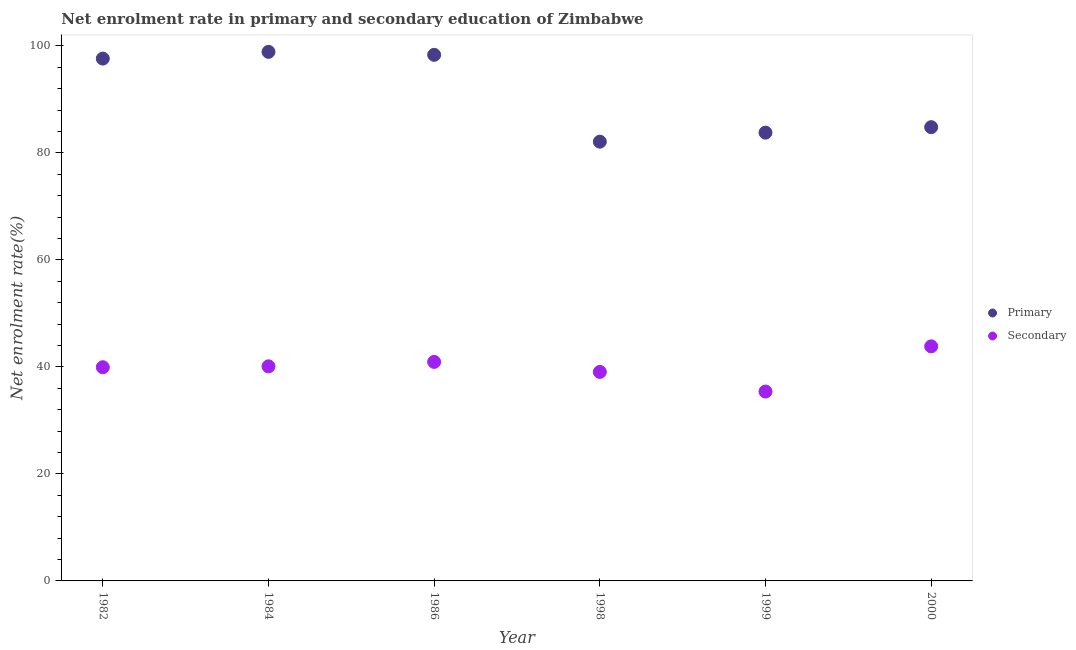How many different coloured dotlines are there?
Your response must be concise. 2. Is the number of dotlines equal to the number of legend labels?
Your answer should be very brief. Yes. What is the enrollment rate in secondary education in 2000?
Your answer should be very brief. 43.84. Across all years, what is the maximum enrollment rate in primary education?
Give a very brief answer. 98.88. Across all years, what is the minimum enrollment rate in primary education?
Ensure brevity in your answer.  82.1. In which year was the enrollment rate in secondary education maximum?
Provide a succinct answer. 2000. In which year was the enrollment rate in primary education minimum?
Your answer should be very brief. 1998. What is the total enrollment rate in secondary education in the graph?
Make the answer very short. 239.28. What is the difference between the enrollment rate in primary education in 1984 and that in 1998?
Ensure brevity in your answer.  16.79. What is the difference between the enrollment rate in secondary education in 1986 and the enrollment rate in primary education in 1984?
Keep it short and to the point. -57.95. What is the average enrollment rate in primary education per year?
Make the answer very short. 90.92. In the year 1999, what is the difference between the enrollment rate in primary education and enrollment rate in secondary education?
Make the answer very short. 48.39. What is the ratio of the enrollment rate in secondary education in 1986 to that in 1998?
Offer a terse response. 1.05. Is the difference between the enrollment rate in primary education in 1982 and 1999 greater than the difference between the enrollment rate in secondary education in 1982 and 1999?
Provide a succinct answer. Yes. What is the difference between the highest and the second highest enrollment rate in secondary education?
Offer a terse response. 2.9. What is the difference between the highest and the lowest enrollment rate in secondary education?
Make the answer very short. 8.44. In how many years, is the enrollment rate in primary education greater than the average enrollment rate in primary education taken over all years?
Provide a short and direct response. 3. Is the enrollment rate in secondary education strictly greater than the enrollment rate in primary education over the years?
Keep it short and to the point. No. Does the graph contain any zero values?
Your response must be concise. No. How many legend labels are there?
Keep it short and to the point. 2. How are the legend labels stacked?
Offer a very short reply. Vertical. What is the title of the graph?
Keep it short and to the point. Net enrolment rate in primary and secondary education of Zimbabwe. Does "Excluding technical cooperation" appear as one of the legend labels in the graph?
Your answer should be compact. No. What is the label or title of the X-axis?
Make the answer very short. Year. What is the label or title of the Y-axis?
Your response must be concise. Net enrolment rate(%). What is the Net enrolment rate(%) in Primary in 1982?
Keep it short and to the point. 97.63. What is the Net enrolment rate(%) in Secondary in 1982?
Your answer should be very brief. 39.94. What is the Net enrolment rate(%) in Primary in 1984?
Make the answer very short. 98.88. What is the Net enrolment rate(%) in Secondary in 1984?
Your answer should be compact. 40.11. What is the Net enrolment rate(%) in Primary in 1986?
Ensure brevity in your answer.  98.33. What is the Net enrolment rate(%) in Secondary in 1986?
Your answer should be compact. 40.93. What is the Net enrolment rate(%) of Primary in 1998?
Your answer should be compact. 82.1. What is the Net enrolment rate(%) of Secondary in 1998?
Your response must be concise. 39.07. What is the Net enrolment rate(%) in Primary in 1999?
Your answer should be very brief. 83.78. What is the Net enrolment rate(%) of Secondary in 1999?
Keep it short and to the point. 35.4. What is the Net enrolment rate(%) of Primary in 2000?
Make the answer very short. 84.81. What is the Net enrolment rate(%) in Secondary in 2000?
Provide a short and direct response. 43.84. Across all years, what is the maximum Net enrolment rate(%) of Primary?
Your answer should be compact. 98.88. Across all years, what is the maximum Net enrolment rate(%) of Secondary?
Provide a succinct answer. 43.84. Across all years, what is the minimum Net enrolment rate(%) in Primary?
Keep it short and to the point. 82.1. Across all years, what is the minimum Net enrolment rate(%) of Secondary?
Your answer should be compact. 35.4. What is the total Net enrolment rate(%) in Primary in the graph?
Keep it short and to the point. 545.52. What is the total Net enrolment rate(%) in Secondary in the graph?
Make the answer very short. 239.28. What is the difference between the Net enrolment rate(%) in Primary in 1982 and that in 1984?
Offer a terse response. -1.26. What is the difference between the Net enrolment rate(%) in Secondary in 1982 and that in 1984?
Offer a terse response. -0.17. What is the difference between the Net enrolment rate(%) of Primary in 1982 and that in 1986?
Your response must be concise. -0.7. What is the difference between the Net enrolment rate(%) in Secondary in 1982 and that in 1986?
Ensure brevity in your answer.  -0.99. What is the difference between the Net enrolment rate(%) of Primary in 1982 and that in 1998?
Provide a short and direct response. 15.53. What is the difference between the Net enrolment rate(%) of Secondary in 1982 and that in 1998?
Give a very brief answer. 0.87. What is the difference between the Net enrolment rate(%) in Primary in 1982 and that in 1999?
Keep it short and to the point. 13.84. What is the difference between the Net enrolment rate(%) of Secondary in 1982 and that in 1999?
Provide a succinct answer. 4.54. What is the difference between the Net enrolment rate(%) in Primary in 1982 and that in 2000?
Keep it short and to the point. 12.82. What is the difference between the Net enrolment rate(%) of Secondary in 1982 and that in 2000?
Give a very brief answer. -3.9. What is the difference between the Net enrolment rate(%) of Primary in 1984 and that in 1986?
Your response must be concise. 0.56. What is the difference between the Net enrolment rate(%) of Secondary in 1984 and that in 1986?
Provide a short and direct response. -0.83. What is the difference between the Net enrolment rate(%) of Primary in 1984 and that in 1998?
Your answer should be compact. 16.79. What is the difference between the Net enrolment rate(%) of Secondary in 1984 and that in 1998?
Provide a succinct answer. 1.04. What is the difference between the Net enrolment rate(%) of Primary in 1984 and that in 1999?
Provide a short and direct response. 15.1. What is the difference between the Net enrolment rate(%) of Secondary in 1984 and that in 1999?
Ensure brevity in your answer.  4.71. What is the difference between the Net enrolment rate(%) in Primary in 1984 and that in 2000?
Your answer should be very brief. 14.07. What is the difference between the Net enrolment rate(%) of Secondary in 1984 and that in 2000?
Ensure brevity in your answer.  -3.73. What is the difference between the Net enrolment rate(%) of Primary in 1986 and that in 1998?
Your response must be concise. 16.23. What is the difference between the Net enrolment rate(%) of Secondary in 1986 and that in 1998?
Give a very brief answer. 1.87. What is the difference between the Net enrolment rate(%) of Primary in 1986 and that in 1999?
Keep it short and to the point. 14.54. What is the difference between the Net enrolment rate(%) of Secondary in 1986 and that in 1999?
Provide a succinct answer. 5.54. What is the difference between the Net enrolment rate(%) of Primary in 1986 and that in 2000?
Make the answer very short. 13.52. What is the difference between the Net enrolment rate(%) in Secondary in 1986 and that in 2000?
Your answer should be compact. -2.9. What is the difference between the Net enrolment rate(%) of Primary in 1998 and that in 1999?
Give a very brief answer. -1.69. What is the difference between the Net enrolment rate(%) of Secondary in 1998 and that in 1999?
Your response must be concise. 3.67. What is the difference between the Net enrolment rate(%) in Primary in 1998 and that in 2000?
Your response must be concise. -2.71. What is the difference between the Net enrolment rate(%) of Secondary in 1998 and that in 2000?
Offer a terse response. -4.77. What is the difference between the Net enrolment rate(%) in Primary in 1999 and that in 2000?
Offer a very short reply. -1.02. What is the difference between the Net enrolment rate(%) of Secondary in 1999 and that in 2000?
Your response must be concise. -8.44. What is the difference between the Net enrolment rate(%) in Primary in 1982 and the Net enrolment rate(%) in Secondary in 1984?
Give a very brief answer. 57.52. What is the difference between the Net enrolment rate(%) in Primary in 1982 and the Net enrolment rate(%) in Secondary in 1986?
Provide a succinct answer. 56.69. What is the difference between the Net enrolment rate(%) in Primary in 1982 and the Net enrolment rate(%) in Secondary in 1998?
Keep it short and to the point. 58.56. What is the difference between the Net enrolment rate(%) of Primary in 1982 and the Net enrolment rate(%) of Secondary in 1999?
Keep it short and to the point. 62.23. What is the difference between the Net enrolment rate(%) of Primary in 1982 and the Net enrolment rate(%) of Secondary in 2000?
Ensure brevity in your answer.  53.79. What is the difference between the Net enrolment rate(%) of Primary in 1984 and the Net enrolment rate(%) of Secondary in 1986?
Your answer should be very brief. 57.95. What is the difference between the Net enrolment rate(%) of Primary in 1984 and the Net enrolment rate(%) of Secondary in 1998?
Your answer should be very brief. 59.82. What is the difference between the Net enrolment rate(%) of Primary in 1984 and the Net enrolment rate(%) of Secondary in 1999?
Offer a very short reply. 63.49. What is the difference between the Net enrolment rate(%) of Primary in 1984 and the Net enrolment rate(%) of Secondary in 2000?
Offer a terse response. 55.05. What is the difference between the Net enrolment rate(%) of Primary in 1986 and the Net enrolment rate(%) of Secondary in 1998?
Offer a terse response. 59.26. What is the difference between the Net enrolment rate(%) in Primary in 1986 and the Net enrolment rate(%) in Secondary in 1999?
Your response must be concise. 62.93. What is the difference between the Net enrolment rate(%) of Primary in 1986 and the Net enrolment rate(%) of Secondary in 2000?
Offer a terse response. 54.49. What is the difference between the Net enrolment rate(%) of Primary in 1998 and the Net enrolment rate(%) of Secondary in 1999?
Make the answer very short. 46.7. What is the difference between the Net enrolment rate(%) of Primary in 1998 and the Net enrolment rate(%) of Secondary in 2000?
Offer a very short reply. 38.26. What is the difference between the Net enrolment rate(%) in Primary in 1999 and the Net enrolment rate(%) in Secondary in 2000?
Make the answer very short. 39.95. What is the average Net enrolment rate(%) of Primary per year?
Provide a succinct answer. 90.92. What is the average Net enrolment rate(%) of Secondary per year?
Your answer should be very brief. 39.88. In the year 1982, what is the difference between the Net enrolment rate(%) of Primary and Net enrolment rate(%) of Secondary?
Your response must be concise. 57.69. In the year 1984, what is the difference between the Net enrolment rate(%) of Primary and Net enrolment rate(%) of Secondary?
Provide a succinct answer. 58.78. In the year 1986, what is the difference between the Net enrolment rate(%) in Primary and Net enrolment rate(%) in Secondary?
Keep it short and to the point. 57.39. In the year 1998, what is the difference between the Net enrolment rate(%) in Primary and Net enrolment rate(%) in Secondary?
Provide a succinct answer. 43.03. In the year 1999, what is the difference between the Net enrolment rate(%) in Primary and Net enrolment rate(%) in Secondary?
Provide a succinct answer. 48.39. In the year 2000, what is the difference between the Net enrolment rate(%) of Primary and Net enrolment rate(%) of Secondary?
Give a very brief answer. 40.97. What is the ratio of the Net enrolment rate(%) in Primary in 1982 to that in 1984?
Ensure brevity in your answer.  0.99. What is the ratio of the Net enrolment rate(%) in Secondary in 1982 to that in 1984?
Keep it short and to the point. 1. What is the ratio of the Net enrolment rate(%) of Secondary in 1982 to that in 1986?
Offer a terse response. 0.98. What is the ratio of the Net enrolment rate(%) in Primary in 1982 to that in 1998?
Give a very brief answer. 1.19. What is the ratio of the Net enrolment rate(%) of Secondary in 1982 to that in 1998?
Your response must be concise. 1.02. What is the ratio of the Net enrolment rate(%) of Primary in 1982 to that in 1999?
Your answer should be very brief. 1.17. What is the ratio of the Net enrolment rate(%) in Secondary in 1982 to that in 1999?
Make the answer very short. 1.13. What is the ratio of the Net enrolment rate(%) of Primary in 1982 to that in 2000?
Provide a succinct answer. 1.15. What is the ratio of the Net enrolment rate(%) in Secondary in 1982 to that in 2000?
Your response must be concise. 0.91. What is the ratio of the Net enrolment rate(%) in Secondary in 1984 to that in 1986?
Provide a succinct answer. 0.98. What is the ratio of the Net enrolment rate(%) in Primary in 1984 to that in 1998?
Make the answer very short. 1.2. What is the ratio of the Net enrolment rate(%) of Secondary in 1984 to that in 1998?
Ensure brevity in your answer.  1.03. What is the ratio of the Net enrolment rate(%) of Primary in 1984 to that in 1999?
Give a very brief answer. 1.18. What is the ratio of the Net enrolment rate(%) in Secondary in 1984 to that in 1999?
Give a very brief answer. 1.13. What is the ratio of the Net enrolment rate(%) in Primary in 1984 to that in 2000?
Ensure brevity in your answer.  1.17. What is the ratio of the Net enrolment rate(%) in Secondary in 1984 to that in 2000?
Offer a terse response. 0.91. What is the ratio of the Net enrolment rate(%) in Primary in 1986 to that in 1998?
Ensure brevity in your answer.  1.2. What is the ratio of the Net enrolment rate(%) of Secondary in 1986 to that in 1998?
Your answer should be compact. 1.05. What is the ratio of the Net enrolment rate(%) of Primary in 1986 to that in 1999?
Keep it short and to the point. 1.17. What is the ratio of the Net enrolment rate(%) of Secondary in 1986 to that in 1999?
Offer a terse response. 1.16. What is the ratio of the Net enrolment rate(%) of Primary in 1986 to that in 2000?
Make the answer very short. 1.16. What is the ratio of the Net enrolment rate(%) in Secondary in 1986 to that in 2000?
Make the answer very short. 0.93. What is the ratio of the Net enrolment rate(%) in Primary in 1998 to that in 1999?
Your answer should be compact. 0.98. What is the ratio of the Net enrolment rate(%) of Secondary in 1998 to that in 1999?
Offer a terse response. 1.1. What is the ratio of the Net enrolment rate(%) in Secondary in 1998 to that in 2000?
Provide a short and direct response. 0.89. What is the ratio of the Net enrolment rate(%) of Primary in 1999 to that in 2000?
Ensure brevity in your answer.  0.99. What is the ratio of the Net enrolment rate(%) in Secondary in 1999 to that in 2000?
Give a very brief answer. 0.81. What is the difference between the highest and the second highest Net enrolment rate(%) of Primary?
Your response must be concise. 0.56. What is the difference between the highest and the second highest Net enrolment rate(%) in Secondary?
Keep it short and to the point. 2.9. What is the difference between the highest and the lowest Net enrolment rate(%) of Primary?
Make the answer very short. 16.79. What is the difference between the highest and the lowest Net enrolment rate(%) in Secondary?
Ensure brevity in your answer.  8.44. 